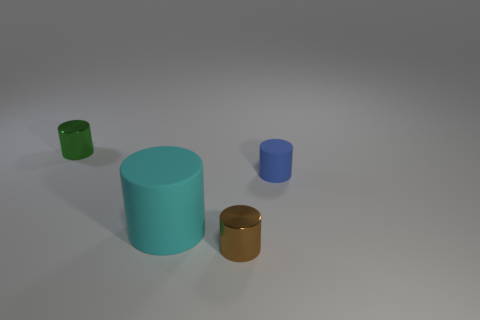Subtract all brown shiny cylinders. How many cylinders are left? 3 Add 2 big red metal spheres. How many objects exist? 6 Subtract 2 cylinders. How many cylinders are left? 2 Subtract all blue cylinders. How many cylinders are left? 3 Subtract all yellow blocks. How many gray cylinders are left? 0 Add 1 rubber objects. How many rubber objects are left? 3 Add 1 blue matte cubes. How many blue matte cubes exist? 1 Subtract 0 yellow cubes. How many objects are left? 4 Subtract all blue cylinders. Subtract all red balls. How many cylinders are left? 3 Subtract all green shiny cylinders. Subtract all small cylinders. How many objects are left? 0 